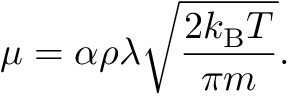<formula> <loc_0><loc_0><loc_500><loc_500>\mu = \alpha \rho \lambda { \sqrt { \frac { 2 k _ { B } T } { \pi m } } } .</formula> 